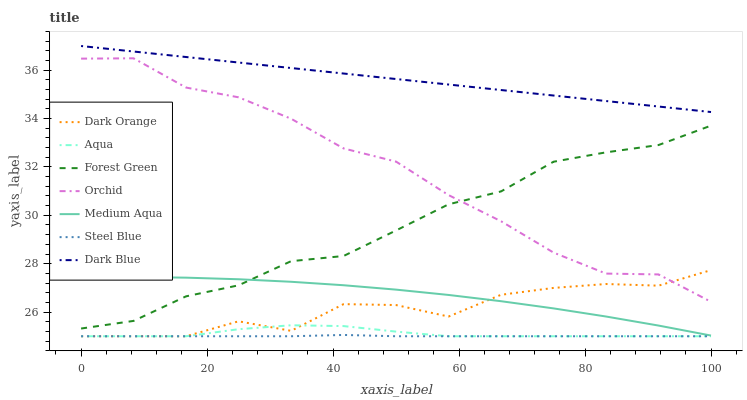Does Steel Blue have the minimum area under the curve?
Answer yes or no. Yes. Does Dark Blue have the maximum area under the curve?
Answer yes or no. Yes. Does Aqua have the minimum area under the curve?
Answer yes or no. No. Does Aqua have the maximum area under the curve?
Answer yes or no. No. Is Dark Blue the smoothest?
Answer yes or no. Yes. Is Dark Orange the roughest?
Answer yes or no. Yes. Is Aqua the smoothest?
Answer yes or no. No. Is Aqua the roughest?
Answer yes or no. No. Does Dark Orange have the lowest value?
Answer yes or no. Yes. Does Dark Blue have the lowest value?
Answer yes or no. No. Does Dark Blue have the highest value?
Answer yes or no. Yes. Does Aqua have the highest value?
Answer yes or no. No. Is Steel Blue less than Medium Aqua?
Answer yes or no. Yes. Is Dark Blue greater than Forest Green?
Answer yes or no. Yes. Does Dark Orange intersect Orchid?
Answer yes or no. Yes. Is Dark Orange less than Orchid?
Answer yes or no. No. Is Dark Orange greater than Orchid?
Answer yes or no. No. Does Steel Blue intersect Medium Aqua?
Answer yes or no. No. 